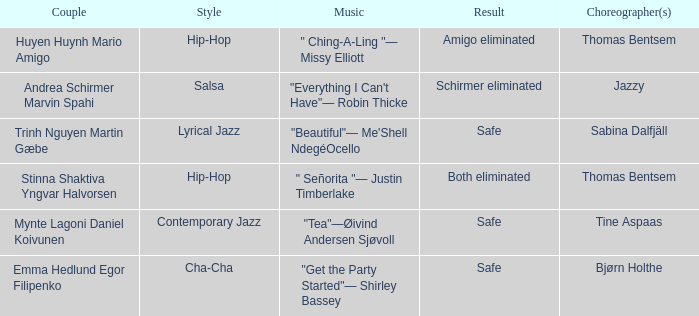What is the music for choreographer sabina dalfjäll? "Beautiful"— Me'Shell NdegéOcello. 